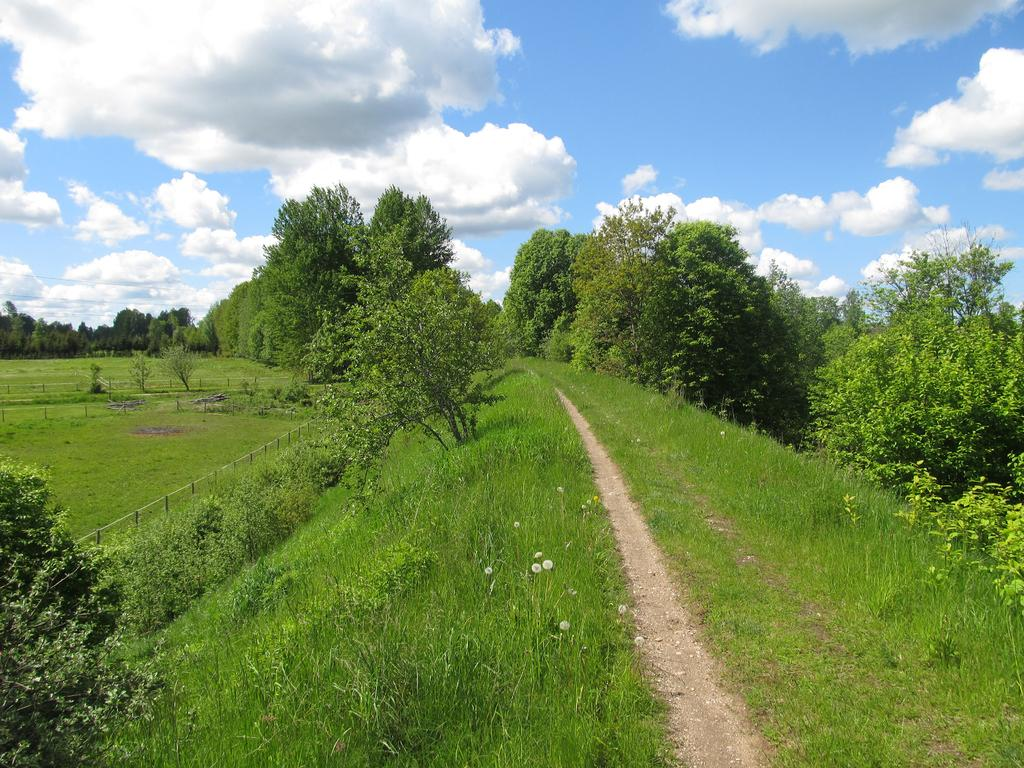What type of vegetation can be seen in the image? There are trees and grass in the image. What is the purpose of the fence in the image? The purpose of the fence in the image is not specified, but it could be for enclosing an area or marking a boundary. What is visible in the background of the image? The sky is visible in the image, and clouds are present in the sky. Can you see a school, ship, or carriage in the image? No, there is no school, ship, or carriage present in the image. 